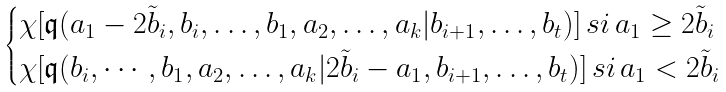<formula> <loc_0><loc_0><loc_500><loc_500>\begin{cases} \chi [ \mathfrak { q } ( a _ { 1 } - 2 \tilde { b } _ { i } , b _ { i } , \dots , b _ { 1 } , a _ { 2 } , \dots , a _ { k } | b _ { i + 1 } , \dots , b _ { t } ) ] \, s i \, a _ { 1 } \geq 2 \tilde { b } _ { i } \\ \chi [ \mathfrak { q } ( b _ { i } , \cdots , b _ { 1 } , a _ { 2 } , \dots , a _ { k } | 2 \tilde { b } _ { i } - a _ { 1 } , b _ { i + 1 } , \dots , b _ { t } ) ] \, s i \, a _ { 1 } < 2 \tilde { b } _ { i } \\ \end{cases}</formula> 